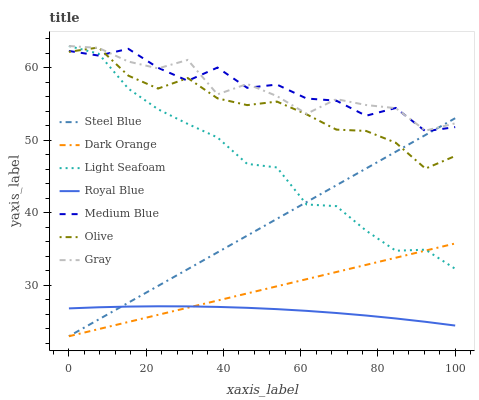Does Royal Blue have the minimum area under the curve?
Answer yes or no. Yes. Does Medium Blue have the maximum area under the curve?
Answer yes or no. Yes. Does Gray have the minimum area under the curve?
Answer yes or no. No. Does Gray have the maximum area under the curve?
Answer yes or no. No. Is Dark Orange the smoothest?
Answer yes or no. Yes. Is Gray the roughest?
Answer yes or no. Yes. Is Medium Blue the smoothest?
Answer yes or no. No. Is Medium Blue the roughest?
Answer yes or no. No. Does Medium Blue have the lowest value?
Answer yes or no. No. Does Medium Blue have the highest value?
Answer yes or no. No. Is Dark Orange less than Olive?
Answer yes or no. Yes. Is Olive greater than Dark Orange?
Answer yes or no. Yes. Does Dark Orange intersect Olive?
Answer yes or no. No. 